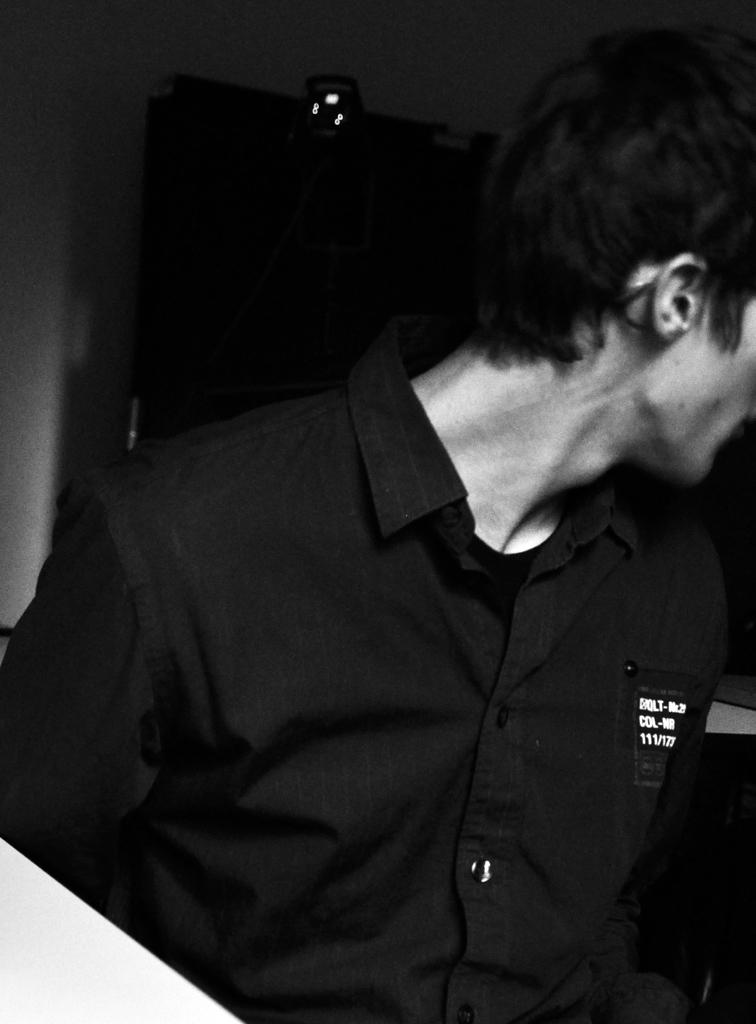Who is present in the image? There is a man in the image. What is the man wearing? The man is wearing a black shirt. Where is the man located in the image? The man is standing near a door and a wall. Can you describe the lighting in the image? There might be a light at the top of the image. What object can be seen in the bottom left corner of the image? There is a table in the bottom left corner of the image. How does the man's partner react to his sneeze in the image? There is no partner present in the image, and the man is not shown sneezing. 